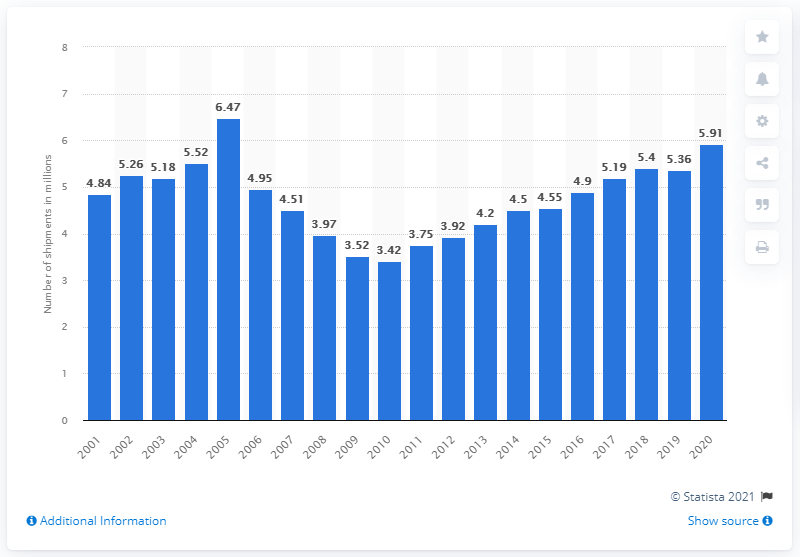Draw attention to some important aspects in this diagram. According to data, a total of 5.91 million air conditioners were shipped in the United States in 2020. In the United States in 2020, a total of 5,910 air conditioners were shipped. 